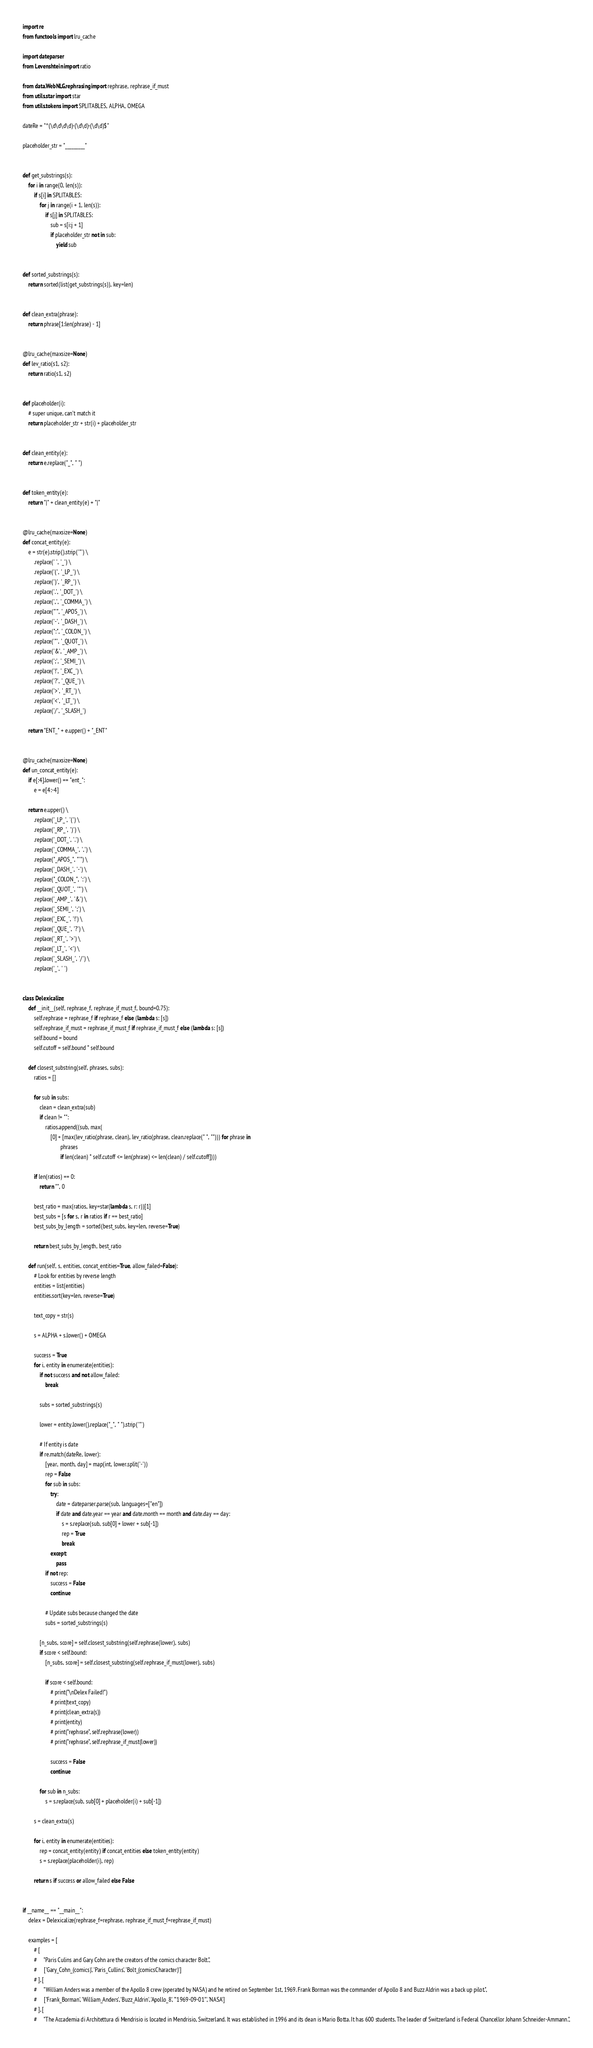Convert code to text. <code><loc_0><loc_0><loc_500><loc_500><_Python_>import re
from functools import lru_cache

import dateparser
from Levenshtein import ratio

from data.WebNLG.rephrasing import rephrase, rephrase_if_must
from utils.star import star
from utils.tokens import SPLITABLES, ALPHA, OMEGA

dateRe = "^(\d\d\d\d)-(\d\d)-(\d\d)$"

placeholder_str = "_________"


def get_substrings(s):
    for i in range(0, len(s)):
        if s[i] in SPLITABLES:
            for j in range(i + 1, len(s)):
                if s[j] in SPLITABLES:
                    sub = s[i:j + 1]
                    if placeholder_str not in sub:
                        yield sub


def sorted_substrings(s):
    return sorted(list(get_substrings(s)), key=len)


def clean_extra(phrase):
    return phrase[1:len(phrase) - 1]


@lru_cache(maxsize=None)
def lev_ratio(s1, s2):
    return ratio(s1, s2)


def placeholder(i):
    # super unique, can't match it
    return placeholder_str + str(i) + placeholder_str


def clean_entity(e):
    return e.replace("_", " ")


def token_entity(e):
    return "|" + clean_entity(e) + "|"


@lru_cache(maxsize=None)
def concat_entity(e):
    e = str(e).strip().strip('"') \
        .replace(' ', '_') \
        .replace('(', '_LP_') \
        .replace(')', '_RP_') \
        .replace('.', '_DOT_') \
        .replace(',', '_COMMA_') \
        .replace("'", '_APOS_') \
        .replace('-', '_DASH_') \
        .replace(":", '_COLON_') \
        .replace('"', '_QUOT_') \
        .replace('&', '_AMP_') \
        .replace(';', '_SEMI_') \
        .replace('!', '_EXC_') \
        .replace('?', '_QUE_') \
        .replace('>', '_RT_') \
        .replace('<', '_LT_') \
        .replace('/', '_SLASH_')

    return "ENT_" + e.upper() + "_ENT"


@lru_cache(maxsize=None)
def un_concat_entity(e):
    if e[:4].lower() == "ent_":
        e = e[4:-4]

    return e.upper() \
        .replace('_LP_', '(') \
        .replace('_RP_', ')') \
        .replace('_DOT_', '.') \
        .replace('_COMMA_', ',') \
        .replace("_APOS_", "'") \
        .replace('_DASH_', '-') \
        .replace("_COLON_", ':') \
        .replace('_QUOT_', '"') \
        .replace('_AMP_', '&') \
        .replace('_SEMI_', ';') \
        .replace('_EXC_', '!') \
        .replace('_QUE_', '?') \
        .replace('_RT_', '>') \
        .replace('_LT_', '<') \
        .replace('_SLASH_', '/') \
        .replace('_', ' ')


class Delexicalize:
    def __init__(self, rephrase_f, rephrase_if_must_f, bound=0.75):
        self.rephrase = rephrase_f if rephrase_f else (lambda s: [s])
        self.rephrase_if_must = rephrase_if_must_f if rephrase_if_must_f else (lambda s: [s])
        self.bound = bound
        self.cutoff = self.bound * self.bound

    def closest_substring(self, phrases, subs):
        ratios = []

        for sub in subs:
            clean = clean_extra(sub)
            if clean != "":
                ratios.append((sub, max(
                    [0] + [max(lev_ratio(phrase, clean), lev_ratio(phrase, clean.replace(" ", ""))) for phrase in
                           phrases
                           if len(clean) * self.cutoff <= len(phrase) <= len(clean) / self.cutoff])))

        if len(ratios) == 0:
            return "", 0

        best_ratio = max(ratios, key=star(lambda s, r: r))[1]
        best_subs = [s for s, r in ratios if r == best_ratio]
        best_subs_by_length = sorted(best_subs, key=len, reverse=True)

        return best_subs_by_length, best_ratio

    def run(self, s, entities, concat_entities=True, allow_failed=False):
        # Look for entities by reverse length
        entities = list(entities)
        entities.sort(key=len, reverse=True)

        text_copy = str(s)

        s = ALPHA + s.lower() + OMEGA

        success = True
        for i, entity in enumerate(entities):
            if not success and not allow_failed:
                break

            subs = sorted_substrings(s)

            lower = entity.lower().replace("_", " ").strip('"')

            # If entity is date
            if re.match(dateRe, lower):
                [year, month, day] = map(int, lower.split('-'))
                rep = False
                for sub in subs:
                    try:
                        date = dateparser.parse(sub, languages=["en"])
                        if date and date.year == year and date.month == month and date.day == day:
                            s = s.replace(sub, sub[0] + lower + sub[-1])
                            rep = True
                            break
                    except:
                        pass
                if not rep:
                    success = False
                    continue

                # Update subs because changed the date
                subs = sorted_substrings(s)

            [n_subs, score] = self.closest_substring(self.rephrase(lower), subs)
            if score < self.bound:
                [n_subs, score] = self.closest_substring(self.rephrase_if_must(lower), subs)

                if score < self.bound:
                    # print("\nDelex Failed!")
                    # print(text_copy)
                    # print(clean_extra(s))
                    # print(entity)
                    # print("rephrase", self.rephrase(lower))
                    # print("rephrase", self.rephrase_if_must(lower))

                    success = False
                    continue

            for sub in n_subs:
                s = s.replace(sub, sub[0] + placeholder(i) + sub[-1])

        s = clean_extra(s)

        for i, entity in enumerate(entities):
            rep = concat_entity(entity) if concat_entities else token_entity(entity)
            s = s.replace(placeholder(i), rep)

        return s if success or allow_failed else False


if __name__ == "__main__":
    delex = Delexicalize(rephrase_f=rephrase, rephrase_if_must_f=rephrase_if_must)

    examples = [
        # [
        #     "Paris Culins and Gary Cohn are the creators of the comics character Bolt.",
        #     ['Gary_Cohn_(comics)', 'Paris_Cullins', 'Bolt_(comicsCharacter)']
        # ], [
        #     "William Anders was a member of the Apollo 8 crew (operated by NASA) and he retired on September 1st, 1969. Frank Borman was the commander of Apollo 8 and Buzz Aldrin was a back up pilot.",
        #     ['Frank_Borman', 'William_Anders', 'Buzz_Aldrin', 'Apollo_8', '"1969-09-01"', 'NASA']
        # ], [
        #     "The Accademia di Architettura di Mendrisio is located in Mendrisio, Switzerland. It was established in 1996 and its dean is Mario Botta. It has 600 students. The leader of Switzerland is Federal Chancellor Johann Schneider-Ammann.",</code> 